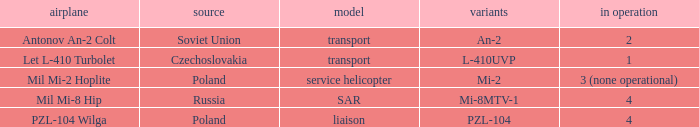Tell me the versions for czechoslovakia? L-410UVP. 